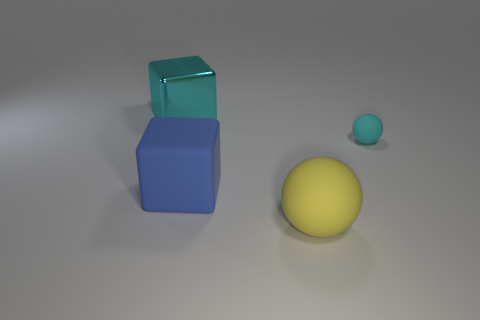How many large shiny objects have the same color as the tiny rubber ball?
Give a very brief answer. 1. How many other objects are there of the same color as the big shiny block?
Keep it short and to the point. 1. Is the number of big yellow matte spheres greater than the number of tiny gray shiny cubes?
Your answer should be compact. Yes. What is the material of the blue block?
Provide a succinct answer. Rubber. Is the size of the cyan thing that is left of the yellow sphere the same as the big ball?
Make the answer very short. Yes. How big is the yellow object in front of the metallic block?
Your answer should be compact. Large. Are there any other things that are the same material as the big yellow sphere?
Provide a succinct answer. Yes. What number of shiny cylinders are there?
Your answer should be very brief. 0. Do the metallic cube and the big ball have the same color?
Provide a succinct answer. No. What is the color of the large object that is to the right of the big cyan object and behind the large yellow ball?
Give a very brief answer. Blue. 